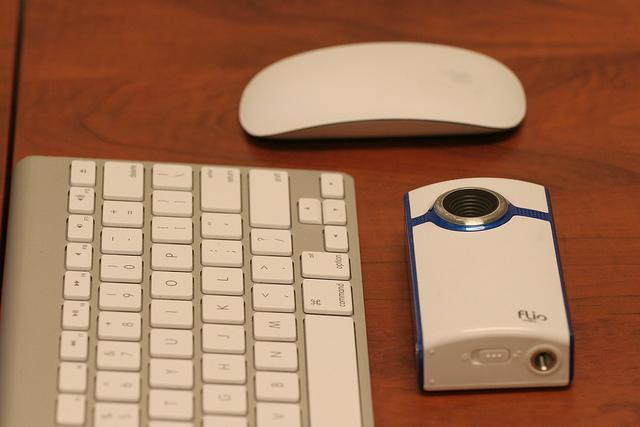What is the device on the left of the picture used for?
Keep it brief. Typing. What is the common color of the three devices?
Quick response, please. White. What is the device at the top of the picture?
Answer briefly. Mouse. 